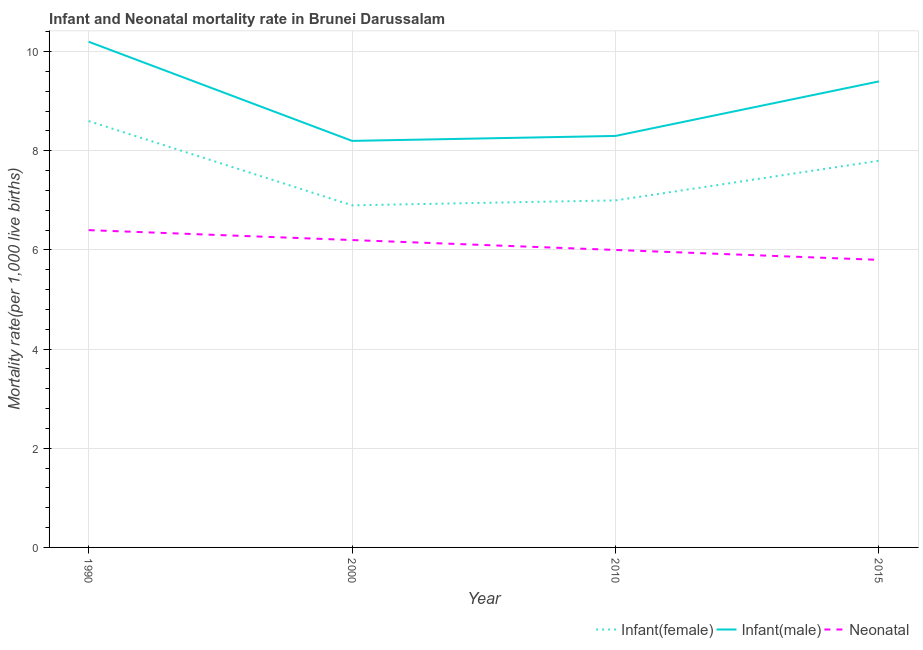How many different coloured lines are there?
Make the answer very short. 3. Does the line corresponding to neonatal mortality rate intersect with the line corresponding to infant mortality rate(female)?
Offer a very short reply. No. What is the neonatal mortality rate in 1990?
Provide a succinct answer. 6.4. Across all years, what is the minimum neonatal mortality rate?
Your answer should be compact. 5.8. In which year was the neonatal mortality rate maximum?
Offer a very short reply. 1990. What is the total infant mortality rate(female) in the graph?
Ensure brevity in your answer.  30.3. What is the difference between the infant mortality rate(female) in 1990 and that in 2015?
Offer a very short reply. 0.8. What is the difference between the infant mortality rate(female) in 2010 and the infant mortality rate(male) in 2000?
Your answer should be very brief. -1.2. What is the average neonatal mortality rate per year?
Give a very brief answer. 6.1. In the year 2000, what is the difference between the infant mortality rate(male) and neonatal mortality rate?
Your answer should be compact. 2. What is the ratio of the infant mortality rate(male) in 2010 to that in 2015?
Give a very brief answer. 0.88. What is the difference between the highest and the second highest infant mortality rate(female)?
Your answer should be compact. 0.8. What is the difference between the highest and the lowest infant mortality rate(female)?
Ensure brevity in your answer.  1.7. In how many years, is the infant mortality rate(female) greater than the average infant mortality rate(female) taken over all years?
Give a very brief answer. 2. Is the sum of the infant mortality rate(female) in 1990 and 2000 greater than the maximum infant mortality rate(male) across all years?
Give a very brief answer. Yes. Is it the case that in every year, the sum of the infant mortality rate(female) and infant mortality rate(male) is greater than the neonatal mortality rate?
Keep it short and to the point. Yes. Does the neonatal mortality rate monotonically increase over the years?
Your response must be concise. No. Is the neonatal mortality rate strictly greater than the infant mortality rate(female) over the years?
Keep it short and to the point. No. Is the infant mortality rate(female) strictly less than the neonatal mortality rate over the years?
Ensure brevity in your answer.  No. How many years are there in the graph?
Your response must be concise. 4. Does the graph contain grids?
Offer a very short reply. Yes. What is the title of the graph?
Your answer should be very brief. Infant and Neonatal mortality rate in Brunei Darussalam. Does "Transport services" appear as one of the legend labels in the graph?
Provide a short and direct response. No. What is the label or title of the X-axis?
Offer a very short reply. Year. What is the label or title of the Y-axis?
Provide a short and direct response. Mortality rate(per 1,0 live births). What is the Mortality rate(per 1,000 live births) in Infant(female) in 1990?
Your response must be concise. 8.6. What is the Mortality rate(per 1,000 live births) of Infant(male) in 1990?
Your answer should be very brief. 10.2. What is the Mortality rate(per 1,000 live births) in Infant(male) in 2000?
Provide a succinct answer. 8.2. What is the Mortality rate(per 1,000 live births) of Neonatal  in 2000?
Provide a succinct answer. 6.2. What is the Mortality rate(per 1,000 live births) in Infant(female) in 2010?
Your answer should be compact. 7. What is the Mortality rate(per 1,000 live births) of Neonatal  in 2010?
Your answer should be very brief. 6. What is the Mortality rate(per 1,000 live births) in Infant(male) in 2015?
Give a very brief answer. 9.4. Across all years, what is the minimum Mortality rate(per 1,000 live births) in Neonatal ?
Your answer should be very brief. 5.8. What is the total Mortality rate(per 1,000 live births) in Infant(female) in the graph?
Ensure brevity in your answer.  30.3. What is the total Mortality rate(per 1,000 live births) of Infant(male) in the graph?
Provide a succinct answer. 36.1. What is the total Mortality rate(per 1,000 live births) of Neonatal  in the graph?
Ensure brevity in your answer.  24.4. What is the difference between the Mortality rate(per 1,000 live births) of Infant(female) in 1990 and that in 2000?
Provide a succinct answer. 1.7. What is the difference between the Mortality rate(per 1,000 live births) of Neonatal  in 1990 and that in 2000?
Provide a succinct answer. 0.2. What is the difference between the Mortality rate(per 1,000 live births) of Neonatal  in 1990 and that in 2010?
Offer a terse response. 0.4. What is the difference between the Mortality rate(per 1,000 live births) in Infant(female) in 2000 and that in 2010?
Your answer should be very brief. -0.1. What is the difference between the Mortality rate(per 1,000 live births) in Infant(male) in 2000 and that in 2010?
Provide a short and direct response. -0.1. What is the difference between the Mortality rate(per 1,000 live births) of Neonatal  in 2000 and that in 2010?
Give a very brief answer. 0.2. What is the difference between the Mortality rate(per 1,000 live births) of Infant(female) in 2000 and that in 2015?
Offer a terse response. -0.9. What is the difference between the Mortality rate(per 1,000 live births) in Infant(female) in 2010 and that in 2015?
Give a very brief answer. -0.8. What is the difference between the Mortality rate(per 1,000 live births) of Infant(female) in 1990 and the Mortality rate(per 1,000 live births) of Infant(male) in 2000?
Keep it short and to the point. 0.4. What is the difference between the Mortality rate(per 1,000 live births) of Infant(female) in 1990 and the Mortality rate(per 1,000 live births) of Neonatal  in 2000?
Your answer should be very brief. 2.4. What is the difference between the Mortality rate(per 1,000 live births) of Infant(male) in 1990 and the Mortality rate(per 1,000 live births) of Neonatal  in 2000?
Offer a terse response. 4. What is the difference between the Mortality rate(per 1,000 live births) in Infant(female) in 1990 and the Mortality rate(per 1,000 live births) in Neonatal  in 2015?
Your answer should be very brief. 2.8. What is the difference between the Mortality rate(per 1,000 live births) in Infant(female) in 2000 and the Mortality rate(per 1,000 live births) in Infant(male) in 2010?
Keep it short and to the point. -1.4. What is the difference between the Mortality rate(per 1,000 live births) in Infant(female) in 2000 and the Mortality rate(per 1,000 live births) in Neonatal  in 2015?
Offer a terse response. 1.1. What is the difference between the Mortality rate(per 1,000 live births) in Infant(male) in 2000 and the Mortality rate(per 1,000 live births) in Neonatal  in 2015?
Your response must be concise. 2.4. What is the average Mortality rate(per 1,000 live births) of Infant(female) per year?
Give a very brief answer. 7.58. What is the average Mortality rate(per 1,000 live births) in Infant(male) per year?
Offer a very short reply. 9.03. In the year 1990, what is the difference between the Mortality rate(per 1,000 live births) of Infant(female) and Mortality rate(per 1,000 live births) of Neonatal ?
Offer a terse response. 2.2. In the year 1990, what is the difference between the Mortality rate(per 1,000 live births) of Infant(male) and Mortality rate(per 1,000 live births) of Neonatal ?
Your response must be concise. 3.8. In the year 2000, what is the difference between the Mortality rate(per 1,000 live births) in Infant(female) and Mortality rate(per 1,000 live births) in Neonatal ?
Your answer should be very brief. 0.7. In the year 2010, what is the difference between the Mortality rate(per 1,000 live births) of Infant(female) and Mortality rate(per 1,000 live births) of Neonatal ?
Offer a very short reply. 1. In the year 2015, what is the difference between the Mortality rate(per 1,000 live births) of Infant(female) and Mortality rate(per 1,000 live births) of Infant(male)?
Offer a very short reply. -1.6. In the year 2015, what is the difference between the Mortality rate(per 1,000 live births) of Infant(female) and Mortality rate(per 1,000 live births) of Neonatal ?
Offer a very short reply. 2. In the year 2015, what is the difference between the Mortality rate(per 1,000 live births) of Infant(male) and Mortality rate(per 1,000 live births) of Neonatal ?
Your answer should be compact. 3.6. What is the ratio of the Mortality rate(per 1,000 live births) in Infant(female) in 1990 to that in 2000?
Keep it short and to the point. 1.25. What is the ratio of the Mortality rate(per 1,000 live births) of Infant(male) in 1990 to that in 2000?
Your answer should be compact. 1.24. What is the ratio of the Mortality rate(per 1,000 live births) of Neonatal  in 1990 to that in 2000?
Offer a very short reply. 1.03. What is the ratio of the Mortality rate(per 1,000 live births) in Infant(female) in 1990 to that in 2010?
Your answer should be compact. 1.23. What is the ratio of the Mortality rate(per 1,000 live births) of Infant(male) in 1990 to that in 2010?
Give a very brief answer. 1.23. What is the ratio of the Mortality rate(per 1,000 live births) in Neonatal  in 1990 to that in 2010?
Keep it short and to the point. 1.07. What is the ratio of the Mortality rate(per 1,000 live births) in Infant(female) in 1990 to that in 2015?
Offer a terse response. 1.1. What is the ratio of the Mortality rate(per 1,000 live births) of Infant(male) in 1990 to that in 2015?
Provide a short and direct response. 1.09. What is the ratio of the Mortality rate(per 1,000 live births) in Neonatal  in 1990 to that in 2015?
Provide a short and direct response. 1.1. What is the ratio of the Mortality rate(per 1,000 live births) in Infant(female) in 2000 to that in 2010?
Ensure brevity in your answer.  0.99. What is the ratio of the Mortality rate(per 1,000 live births) in Infant(female) in 2000 to that in 2015?
Provide a succinct answer. 0.88. What is the ratio of the Mortality rate(per 1,000 live births) in Infant(male) in 2000 to that in 2015?
Offer a terse response. 0.87. What is the ratio of the Mortality rate(per 1,000 live births) in Neonatal  in 2000 to that in 2015?
Your answer should be compact. 1.07. What is the ratio of the Mortality rate(per 1,000 live births) of Infant(female) in 2010 to that in 2015?
Provide a succinct answer. 0.9. What is the ratio of the Mortality rate(per 1,000 live births) in Infant(male) in 2010 to that in 2015?
Provide a short and direct response. 0.88. What is the ratio of the Mortality rate(per 1,000 live births) in Neonatal  in 2010 to that in 2015?
Offer a very short reply. 1.03. What is the difference between the highest and the second highest Mortality rate(per 1,000 live births) in Infant(female)?
Your response must be concise. 0.8. What is the difference between the highest and the second highest Mortality rate(per 1,000 live births) of Infant(male)?
Your answer should be compact. 0.8. What is the difference between the highest and the lowest Mortality rate(per 1,000 live births) of Infant(male)?
Ensure brevity in your answer.  2. What is the difference between the highest and the lowest Mortality rate(per 1,000 live births) in Neonatal ?
Offer a terse response. 0.6. 